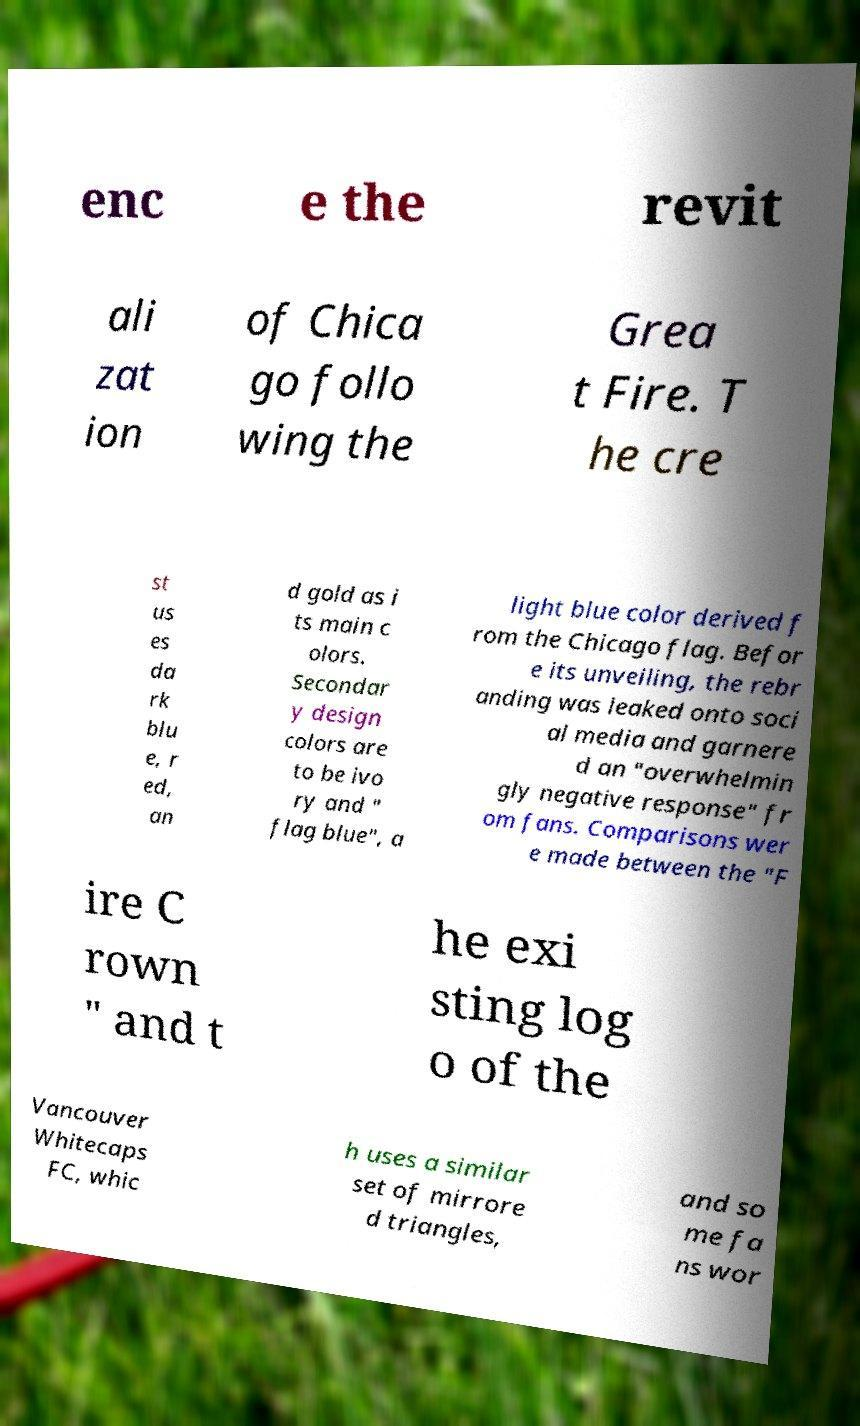Could you assist in decoding the text presented in this image and type it out clearly? enc e the revit ali zat ion of Chica go follo wing the Grea t Fire. T he cre st us es da rk blu e, r ed, an d gold as i ts main c olors. Secondar y design colors are to be ivo ry and " flag blue", a light blue color derived f rom the Chicago flag. Befor e its unveiling, the rebr anding was leaked onto soci al media and garnere d an "overwhelmin gly negative response" fr om fans. Comparisons wer e made between the "F ire C rown " and t he exi sting log o of the Vancouver Whitecaps FC, whic h uses a similar set of mirrore d triangles, and so me fa ns wor 